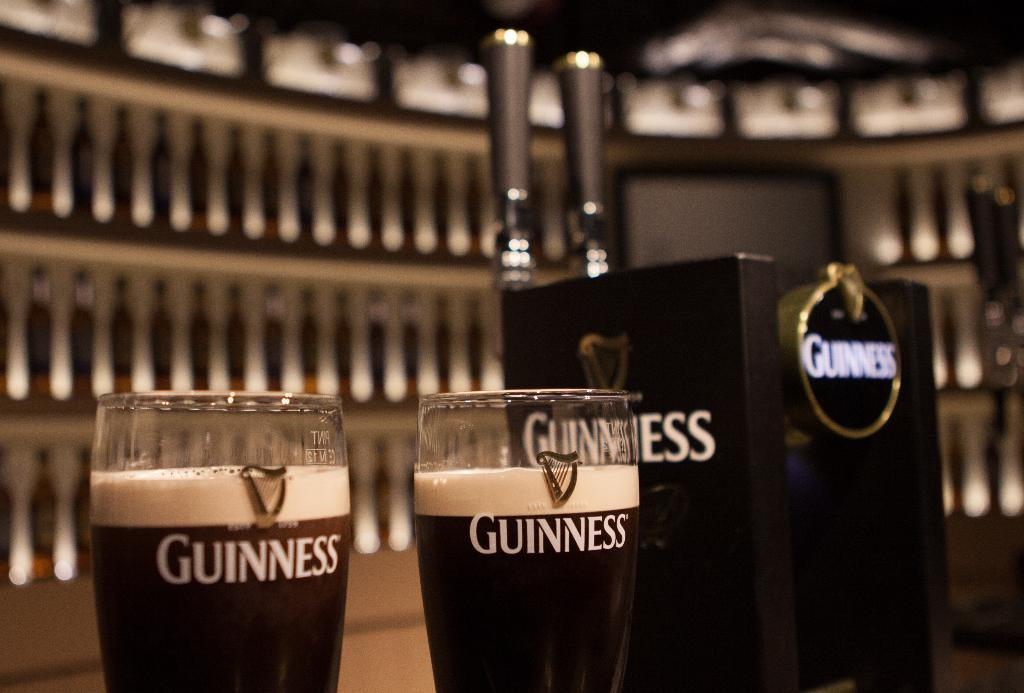<image>
Relay a brief, clear account of the picture shown. Two Guinness glasses are next to a Guinness bar tap. 